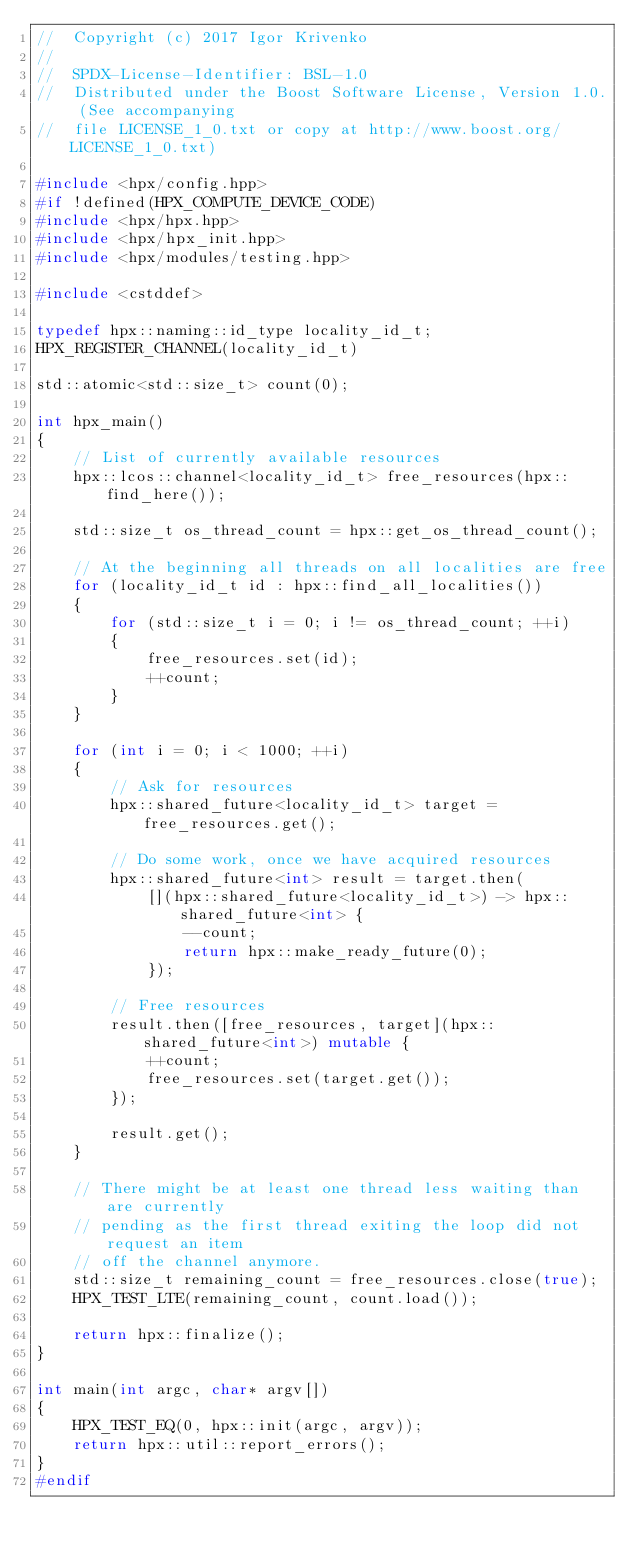<code> <loc_0><loc_0><loc_500><loc_500><_C++_>//  Copyright (c) 2017 Igor Krivenko
//
//  SPDX-License-Identifier: BSL-1.0
//  Distributed under the Boost Software License, Version 1.0. (See accompanying
//  file LICENSE_1_0.txt or copy at http://www.boost.org/LICENSE_1_0.txt)

#include <hpx/config.hpp>
#if !defined(HPX_COMPUTE_DEVICE_CODE)
#include <hpx/hpx.hpp>
#include <hpx/hpx_init.hpp>
#include <hpx/modules/testing.hpp>

#include <cstddef>

typedef hpx::naming::id_type locality_id_t;
HPX_REGISTER_CHANNEL(locality_id_t)

std::atomic<std::size_t> count(0);

int hpx_main()
{
    // List of currently available resources
    hpx::lcos::channel<locality_id_t> free_resources(hpx::find_here());

    std::size_t os_thread_count = hpx::get_os_thread_count();

    // At the beginning all threads on all localities are free
    for (locality_id_t id : hpx::find_all_localities())
    {
        for (std::size_t i = 0; i != os_thread_count; ++i)
        {
            free_resources.set(id);
            ++count;
        }
    }

    for (int i = 0; i < 1000; ++i)
    {
        // Ask for resources
        hpx::shared_future<locality_id_t> target = free_resources.get();

        // Do some work, once we have acquired resources
        hpx::shared_future<int> result = target.then(
            [](hpx::shared_future<locality_id_t>) -> hpx::shared_future<int> {
                --count;
                return hpx::make_ready_future(0);
            });

        // Free resources
        result.then([free_resources, target](hpx::shared_future<int>) mutable {
            ++count;
            free_resources.set(target.get());
        });

        result.get();
    }

    // There might be at least one thread less waiting than are currently
    // pending as the first thread exiting the loop did not request an item
    // off the channel anymore.
    std::size_t remaining_count = free_resources.close(true);
    HPX_TEST_LTE(remaining_count, count.load());

    return hpx::finalize();
}

int main(int argc, char* argv[])
{
    HPX_TEST_EQ(0, hpx::init(argc, argv));
    return hpx::util::report_errors();
}
#endif
</code> 